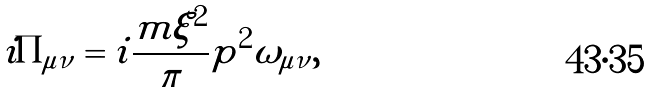<formula> <loc_0><loc_0><loc_500><loc_500>i \Pi _ { \mu \nu } = i \frac { m \xi ^ { 2 } } { \pi } p ^ { 2 } \omega _ { \mu \nu } ,</formula> 